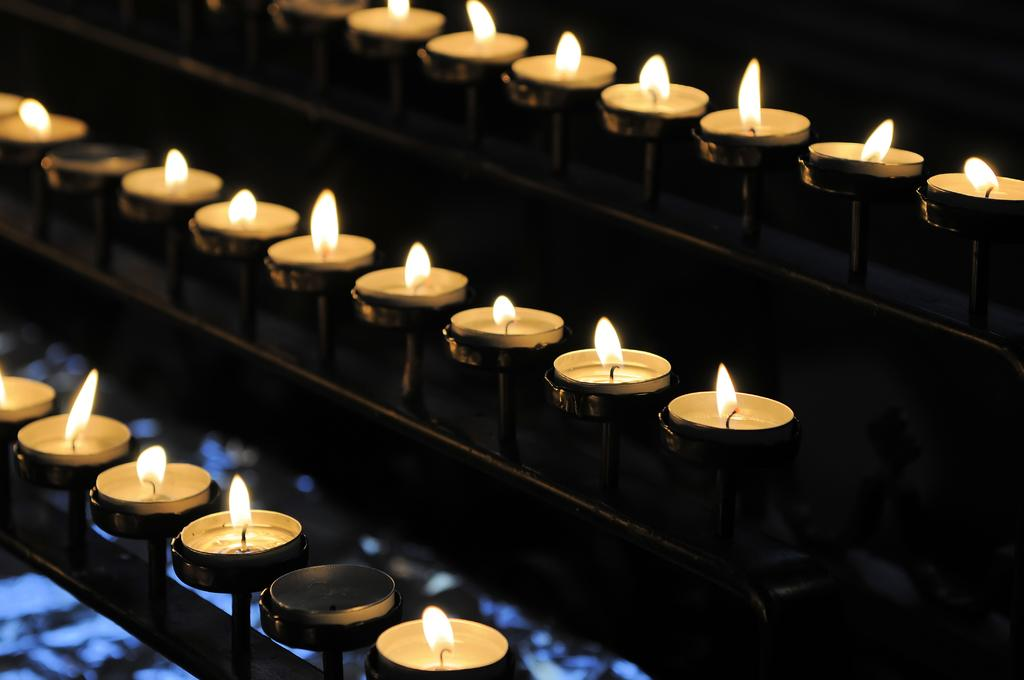What type of small light sources are present in the image? There are lighted tea candles in the image. What else can be seen in the image besides the tea candles? There are rods in the image. What type of crook can be seen interacting with the tea candles in the image? There is no crook present in the image, and therefore no such interaction can be observed. 